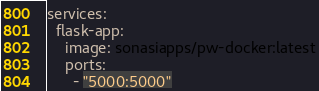<code> <loc_0><loc_0><loc_500><loc_500><_YAML_>services:
  flask-app:
    image: sonasiapps/pw-docker:latest
    ports:
      - "5000:5000"
</code> 